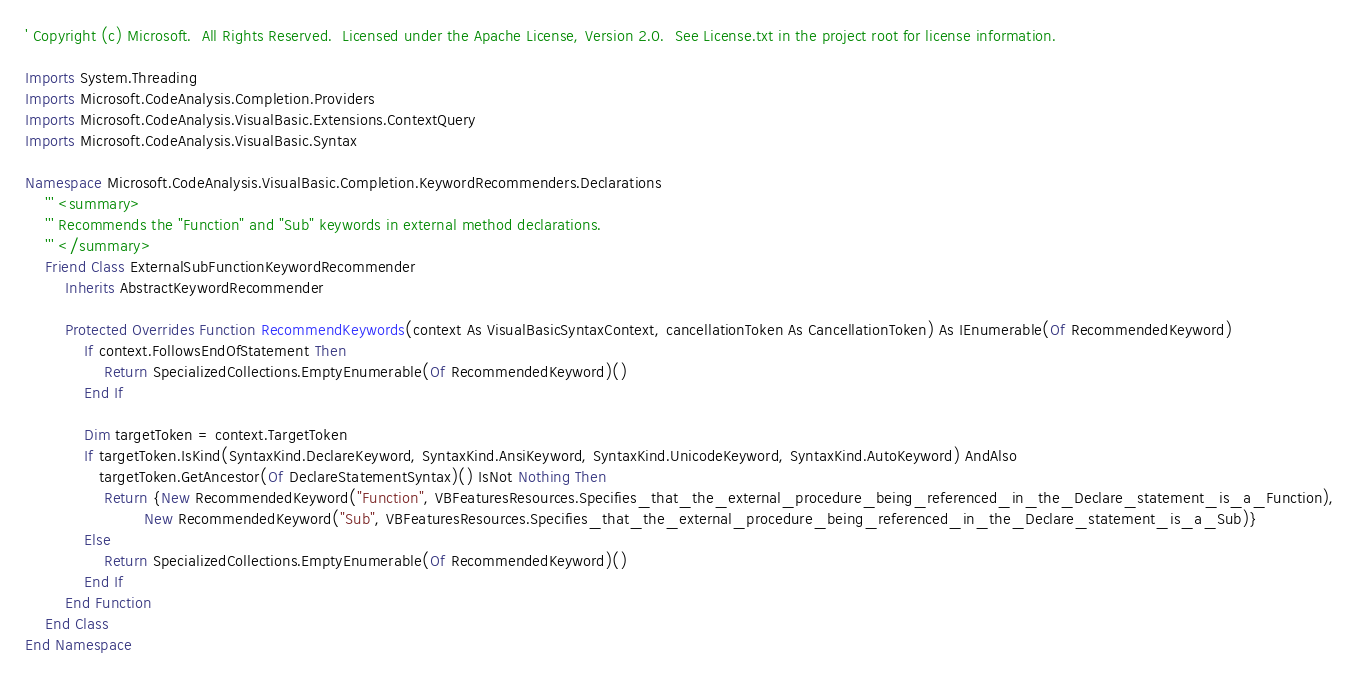<code> <loc_0><loc_0><loc_500><loc_500><_VisualBasic_>' Copyright (c) Microsoft.  All Rights Reserved.  Licensed under the Apache License, Version 2.0.  See License.txt in the project root for license information.

Imports System.Threading
Imports Microsoft.CodeAnalysis.Completion.Providers
Imports Microsoft.CodeAnalysis.VisualBasic.Extensions.ContextQuery
Imports Microsoft.CodeAnalysis.VisualBasic.Syntax

Namespace Microsoft.CodeAnalysis.VisualBasic.Completion.KeywordRecommenders.Declarations
    ''' <summary>
    ''' Recommends the "Function" and "Sub" keywords in external method declarations.
    ''' </summary>
    Friend Class ExternalSubFunctionKeywordRecommender
        Inherits AbstractKeywordRecommender

        Protected Overrides Function RecommendKeywords(context As VisualBasicSyntaxContext, cancellationToken As CancellationToken) As IEnumerable(Of RecommendedKeyword)
            If context.FollowsEndOfStatement Then
                Return SpecializedCollections.EmptyEnumerable(Of RecommendedKeyword)()
            End If

            Dim targetToken = context.TargetToken
            If targetToken.IsKind(SyntaxKind.DeclareKeyword, SyntaxKind.AnsiKeyword, SyntaxKind.UnicodeKeyword, SyntaxKind.AutoKeyword) AndAlso
               targetToken.GetAncestor(Of DeclareStatementSyntax)() IsNot Nothing Then
                Return {New RecommendedKeyword("Function", VBFeaturesResources.Specifies_that_the_external_procedure_being_referenced_in_the_Declare_statement_is_a_Function),
                        New RecommendedKeyword("Sub", VBFeaturesResources.Specifies_that_the_external_procedure_being_referenced_in_the_Declare_statement_is_a_Sub)}
            Else
                Return SpecializedCollections.EmptyEnumerable(Of RecommendedKeyword)()
            End If
        End Function
    End Class
End Namespace
</code> 